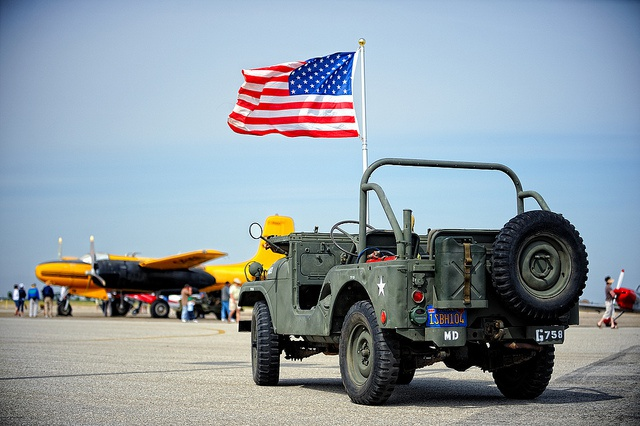Describe the objects in this image and their specific colors. I can see truck in darkblue, black, gray, lightblue, and darkgray tones, airplane in darkblue, black, gold, orange, and maroon tones, people in darkblue, lightgray, darkgray, gray, and black tones, people in darkblue, beige, tan, and darkgray tones, and people in darkblue, gray, tan, black, and lightblue tones in this image. 